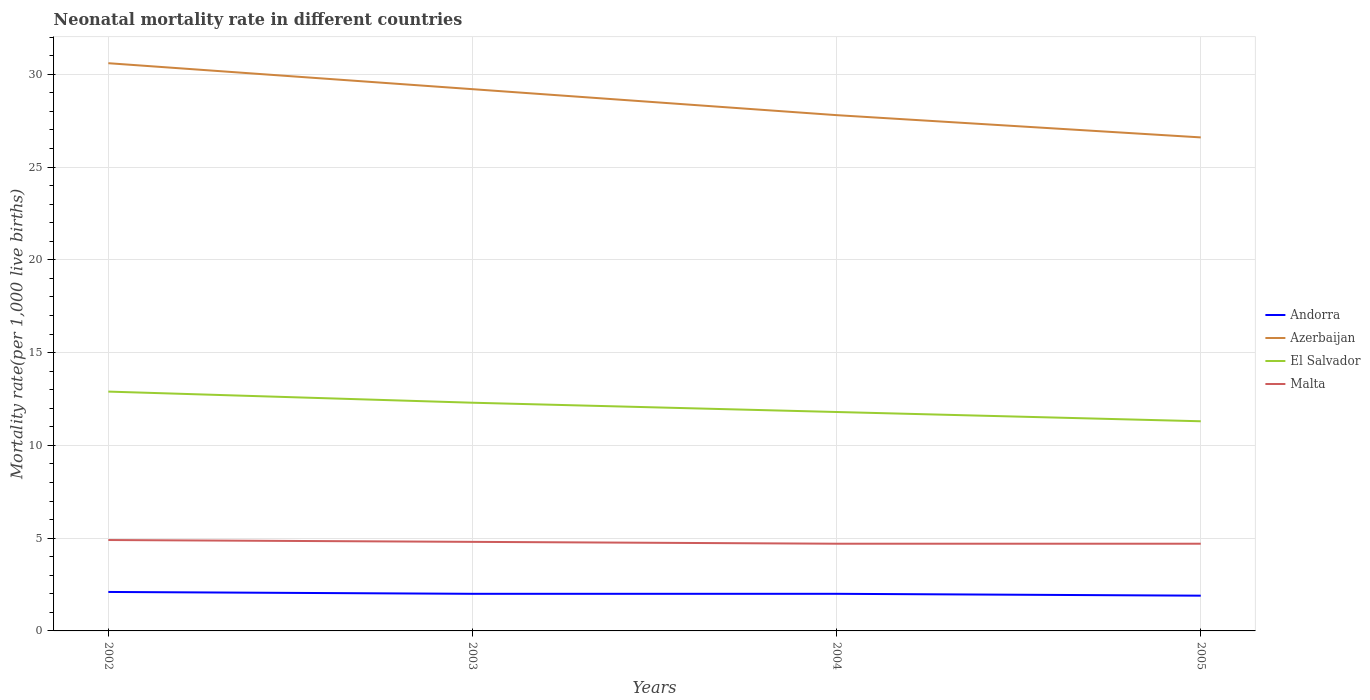What is the total neonatal mortality rate in Malta in the graph?
Provide a short and direct response. 0.2. What is the difference between the highest and the second highest neonatal mortality rate in Azerbaijan?
Provide a short and direct response. 4. Is the neonatal mortality rate in Andorra strictly greater than the neonatal mortality rate in El Salvador over the years?
Offer a terse response. Yes. How many years are there in the graph?
Your answer should be very brief. 4. Are the values on the major ticks of Y-axis written in scientific E-notation?
Your answer should be compact. No. Does the graph contain any zero values?
Provide a short and direct response. No. Does the graph contain grids?
Give a very brief answer. Yes. Where does the legend appear in the graph?
Ensure brevity in your answer.  Center right. How are the legend labels stacked?
Offer a very short reply. Vertical. What is the title of the graph?
Make the answer very short. Neonatal mortality rate in different countries. Does "Moldova" appear as one of the legend labels in the graph?
Keep it short and to the point. No. What is the label or title of the X-axis?
Your response must be concise. Years. What is the label or title of the Y-axis?
Offer a terse response. Mortality rate(per 1,0 live births). What is the Mortality rate(per 1,000 live births) in Azerbaijan in 2002?
Offer a very short reply. 30.6. What is the Mortality rate(per 1,000 live births) in Malta in 2002?
Your response must be concise. 4.9. What is the Mortality rate(per 1,000 live births) in Andorra in 2003?
Offer a terse response. 2. What is the Mortality rate(per 1,000 live births) of Azerbaijan in 2003?
Give a very brief answer. 29.2. What is the Mortality rate(per 1,000 live births) in El Salvador in 2003?
Ensure brevity in your answer.  12.3. What is the Mortality rate(per 1,000 live births) in Malta in 2003?
Your answer should be very brief. 4.8. What is the Mortality rate(per 1,000 live births) in Andorra in 2004?
Ensure brevity in your answer.  2. What is the Mortality rate(per 1,000 live births) in Azerbaijan in 2004?
Your response must be concise. 27.8. What is the Mortality rate(per 1,000 live births) of El Salvador in 2004?
Make the answer very short. 11.8. What is the Mortality rate(per 1,000 live births) in Malta in 2004?
Ensure brevity in your answer.  4.7. What is the Mortality rate(per 1,000 live births) of Andorra in 2005?
Keep it short and to the point. 1.9. What is the Mortality rate(per 1,000 live births) of Azerbaijan in 2005?
Your answer should be very brief. 26.6. What is the Mortality rate(per 1,000 live births) of Malta in 2005?
Your answer should be compact. 4.7. Across all years, what is the maximum Mortality rate(per 1,000 live births) of Azerbaijan?
Give a very brief answer. 30.6. Across all years, what is the maximum Mortality rate(per 1,000 live births) of Malta?
Offer a terse response. 4.9. Across all years, what is the minimum Mortality rate(per 1,000 live births) of Andorra?
Ensure brevity in your answer.  1.9. Across all years, what is the minimum Mortality rate(per 1,000 live births) in Azerbaijan?
Make the answer very short. 26.6. Across all years, what is the minimum Mortality rate(per 1,000 live births) in Malta?
Offer a very short reply. 4.7. What is the total Mortality rate(per 1,000 live births) in Andorra in the graph?
Provide a succinct answer. 8. What is the total Mortality rate(per 1,000 live births) of Azerbaijan in the graph?
Give a very brief answer. 114.2. What is the total Mortality rate(per 1,000 live births) of El Salvador in the graph?
Make the answer very short. 48.3. What is the difference between the Mortality rate(per 1,000 live births) in Andorra in 2002 and that in 2003?
Your answer should be very brief. 0.1. What is the difference between the Mortality rate(per 1,000 live births) of Azerbaijan in 2002 and that in 2003?
Give a very brief answer. 1.4. What is the difference between the Mortality rate(per 1,000 live births) in El Salvador in 2002 and that in 2003?
Offer a terse response. 0.6. What is the difference between the Mortality rate(per 1,000 live births) of Andorra in 2002 and that in 2004?
Make the answer very short. 0.1. What is the difference between the Mortality rate(per 1,000 live births) in Azerbaijan in 2002 and that in 2004?
Provide a short and direct response. 2.8. What is the difference between the Mortality rate(per 1,000 live births) in Malta in 2002 and that in 2004?
Your answer should be very brief. 0.2. What is the difference between the Mortality rate(per 1,000 live births) in El Salvador in 2002 and that in 2005?
Offer a very short reply. 1.6. What is the difference between the Mortality rate(per 1,000 live births) in Andorra in 2003 and that in 2004?
Offer a terse response. 0. What is the difference between the Mortality rate(per 1,000 live births) in Azerbaijan in 2003 and that in 2004?
Provide a succinct answer. 1.4. What is the difference between the Mortality rate(per 1,000 live births) of El Salvador in 2003 and that in 2004?
Provide a succinct answer. 0.5. What is the difference between the Mortality rate(per 1,000 live births) of Malta in 2003 and that in 2004?
Offer a terse response. 0.1. What is the difference between the Mortality rate(per 1,000 live births) of Andorra in 2003 and that in 2005?
Provide a short and direct response. 0.1. What is the difference between the Mortality rate(per 1,000 live births) in El Salvador in 2003 and that in 2005?
Offer a terse response. 1. What is the difference between the Mortality rate(per 1,000 live births) in Malta in 2003 and that in 2005?
Offer a very short reply. 0.1. What is the difference between the Mortality rate(per 1,000 live births) in Malta in 2004 and that in 2005?
Your answer should be compact. 0. What is the difference between the Mortality rate(per 1,000 live births) of Andorra in 2002 and the Mortality rate(per 1,000 live births) of Azerbaijan in 2003?
Offer a very short reply. -27.1. What is the difference between the Mortality rate(per 1,000 live births) in Andorra in 2002 and the Mortality rate(per 1,000 live births) in El Salvador in 2003?
Provide a succinct answer. -10.2. What is the difference between the Mortality rate(per 1,000 live births) in Andorra in 2002 and the Mortality rate(per 1,000 live births) in Malta in 2003?
Ensure brevity in your answer.  -2.7. What is the difference between the Mortality rate(per 1,000 live births) in Azerbaijan in 2002 and the Mortality rate(per 1,000 live births) in Malta in 2003?
Provide a succinct answer. 25.8. What is the difference between the Mortality rate(per 1,000 live births) in El Salvador in 2002 and the Mortality rate(per 1,000 live births) in Malta in 2003?
Give a very brief answer. 8.1. What is the difference between the Mortality rate(per 1,000 live births) of Andorra in 2002 and the Mortality rate(per 1,000 live births) of Azerbaijan in 2004?
Your response must be concise. -25.7. What is the difference between the Mortality rate(per 1,000 live births) in Andorra in 2002 and the Mortality rate(per 1,000 live births) in Malta in 2004?
Keep it short and to the point. -2.6. What is the difference between the Mortality rate(per 1,000 live births) in Azerbaijan in 2002 and the Mortality rate(per 1,000 live births) in El Salvador in 2004?
Your answer should be compact. 18.8. What is the difference between the Mortality rate(per 1,000 live births) in Azerbaijan in 2002 and the Mortality rate(per 1,000 live births) in Malta in 2004?
Your response must be concise. 25.9. What is the difference between the Mortality rate(per 1,000 live births) in Andorra in 2002 and the Mortality rate(per 1,000 live births) in Azerbaijan in 2005?
Ensure brevity in your answer.  -24.5. What is the difference between the Mortality rate(per 1,000 live births) in Andorra in 2002 and the Mortality rate(per 1,000 live births) in El Salvador in 2005?
Offer a very short reply. -9.2. What is the difference between the Mortality rate(per 1,000 live births) of Andorra in 2002 and the Mortality rate(per 1,000 live births) of Malta in 2005?
Keep it short and to the point. -2.6. What is the difference between the Mortality rate(per 1,000 live births) in Azerbaijan in 2002 and the Mortality rate(per 1,000 live births) in El Salvador in 2005?
Keep it short and to the point. 19.3. What is the difference between the Mortality rate(per 1,000 live births) in Azerbaijan in 2002 and the Mortality rate(per 1,000 live births) in Malta in 2005?
Give a very brief answer. 25.9. What is the difference between the Mortality rate(per 1,000 live births) of El Salvador in 2002 and the Mortality rate(per 1,000 live births) of Malta in 2005?
Make the answer very short. 8.2. What is the difference between the Mortality rate(per 1,000 live births) in Andorra in 2003 and the Mortality rate(per 1,000 live births) in Azerbaijan in 2004?
Ensure brevity in your answer.  -25.8. What is the difference between the Mortality rate(per 1,000 live births) of Andorra in 2003 and the Mortality rate(per 1,000 live births) of Malta in 2004?
Ensure brevity in your answer.  -2.7. What is the difference between the Mortality rate(per 1,000 live births) of Azerbaijan in 2003 and the Mortality rate(per 1,000 live births) of El Salvador in 2004?
Keep it short and to the point. 17.4. What is the difference between the Mortality rate(per 1,000 live births) in Andorra in 2003 and the Mortality rate(per 1,000 live births) in Azerbaijan in 2005?
Ensure brevity in your answer.  -24.6. What is the difference between the Mortality rate(per 1,000 live births) of Andorra in 2003 and the Mortality rate(per 1,000 live births) of El Salvador in 2005?
Give a very brief answer. -9.3. What is the difference between the Mortality rate(per 1,000 live births) in Andorra in 2003 and the Mortality rate(per 1,000 live births) in Malta in 2005?
Your answer should be very brief. -2.7. What is the difference between the Mortality rate(per 1,000 live births) in El Salvador in 2003 and the Mortality rate(per 1,000 live births) in Malta in 2005?
Your response must be concise. 7.6. What is the difference between the Mortality rate(per 1,000 live births) of Andorra in 2004 and the Mortality rate(per 1,000 live births) of Azerbaijan in 2005?
Keep it short and to the point. -24.6. What is the difference between the Mortality rate(per 1,000 live births) of Andorra in 2004 and the Mortality rate(per 1,000 live births) of El Salvador in 2005?
Provide a succinct answer. -9.3. What is the difference between the Mortality rate(per 1,000 live births) of Andorra in 2004 and the Mortality rate(per 1,000 live births) of Malta in 2005?
Offer a very short reply. -2.7. What is the difference between the Mortality rate(per 1,000 live births) in Azerbaijan in 2004 and the Mortality rate(per 1,000 live births) in Malta in 2005?
Your answer should be compact. 23.1. What is the average Mortality rate(per 1,000 live births) in Azerbaijan per year?
Offer a very short reply. 28.55. What is the average Mortality rate(per 1,000 live births) in El Salvador per year?
Your answer should be compact. 12.07. What is the average Mortality rate(per 1,000 live births) of Malta per year?
Your response must be concise. 4.78. In the year 2002, what is the difference between the Mortality rate(per 1,000 live births) in Andorra and Mortality rate(per 1,000 live births) in Azerbaijan?
Your response must be concise. -28.5. In the year 2002, what is the difference between the Mortality rate(per 1,000 live births) in Andorra and Mortality rate(per 1,000 live births) in El Salvador?
Provide a succinct answer. -10.8. In the year 2002, what is the difference between the Mortality rate(per 1,000 live births) in Azerbaijan and Mortality rate(per 1,000 live births) in El Salvador?
Offer a terse response. 17.7. In the year 2002, what is the difference between the Mortality rate(per 1,000 live births) of Azerbaijan and Mortality rate(per 1,000 live births) of Malta?
Your answer should be very brief. 25.7. In the year 2003, what is the difference between the Mortality rate(per 1,000 live births) in Andorra and Mortality rate(per 1,000 live births) in Azerbaijan?
Your response must be concise. -27.2. In the year 2003, what is the difference between the Mortality rate(per 1,000 live births) in Andorra and Mortality rate(per 1,000 live births) in El Salvador?
Your answer should be very brief. -10.3. In the year 2003, what is the difference between the Mortality rate(per 1,000 live births) in Andorra and Mortality rate(per 1,000 live births) in Malta?
Give a very brief answer. -2.8. In the year 2003, what is the difference between the Mortality rate(per 1,000 live births) in Azerbaijan and Mortality rate(per 1,000 live births) in Malta?
Offer a very short reply. 24.4. In the year 2004, what is the difference between the Mortality rate(per 1,000 live births) in Andorra and Mortality rate(per 1,000 live births) in Azerbaijan?
Ensure brevity in your answer.  -25.8. In the year 2004, what is the difference between the Mortality rate(per 1,000 live births) in Azerbaijan and Mortality rate(per 1,000 live births) in El Salvador?
Ensure brevity in your answer.  16. In the year 2004, what is the difference between the Mortality rate(per 1,000 live births) in Azerbaijan and Mortality rate(per 1,000 live births) in Malta?
Offer a very short reply. 23.1. In the year 2005, what is the difference between the Mortality rate(per 1,000 live births) of Andorra and Mortality rate(per 1,000 live births) of Azerbaijan?
Offer a terse response. -24.7. In the year 2005, what is the difference between the Mortality rate(per 1,000 live births) of Andorra and Mortality rate(per 1,000 live births) of El Salvador?
Provide a succinct answer. -9.4. In the year 2005, what is the difference between the Mortality rate(per 1,000 live births) in Andorra and Mortality rate(per 1,000 live births) in Malta?
Keep it short and to the point. -2.8. In the year 2005, what is the difference between the Mortality rate(per 1,000 live births) in Azerbaijan and Mortality rate(per 1,000 live births) in El Salvador?
Ensure brevity in your answer.  15.3. In the year 2005, what is the difference between the Mortality rate(per 1,000 live births) of Azerbaijan and Mortality rate(per 1,000 live births) of Malta?
Your answer should be compact. 21.9. In the year 2005, what is the difference between the Mortality rate(per 1,000 live births) of El Salvador and Mortality rate(per 1,000 live births) of Malta?
Provide a short and direct response. 6.6. What is the ratio of the Mortality rate(per 1,000 live births) of Azerbaijan in 2002 to that in 2003?
Give a very brief answer. 1.05. What is the ratio of the Mortality rate(per 1,000 live births) of El Salvador in 2002 to that in 2003?
Make the answer very short. 1.05. What is the ratio of the Mortality rate(per 1,000 live births) in Malta in 2002 to that in 2003?
Give a very brief answer. 1.02. What is the ratio of the Mortality rate(per 1,000 live births) of Andorra in 2002 to that in 2004?
Offer a terse response. 1.05. What is the ratio of the Mortality rate(per 1,000 live births) in Azerbaijan in 2002 to that in 2004?
Offer a terse response. 1.1. What is the ratio of the Mortality rate(per 1,000 live births) of El Salvador in 2002 to that in 2004?
Your response must be concise. 1.09. What is the ratio of the Mortality rate(per 1,000 live births) of Malta in 2002 to that in 2004?
Provide a succinct answer. 1.04. What is the ratio of the Mortality rate(per 1,000 live births) of Andorra in 2002 to that in 2005?
Offer a very short reply. 1.11. What is the ratio of the Mortality rate(per 1,000 live births) of Azerbaijan in 2002 to that in 2005?
Your response must be concise. 1.15. What is the ratio of the Mortality rate(per 1,000 live births) of El Salvador in 2002 to that in 2005?
Your response must be concise. 1.14. What is the ratio of the Mortality rate(per 1,000 live births) of Malta in 2002 to that in 2005?
Give a very brief answer. 1.04. What is the ratio of the Mortality rate(per 1,000 live births) in Azerbaijan in 2003 to that in 2004?
Give a very brief answer. 1.05. What is the ratio of the Mortality rate(per 1,000 live births) in El Salvador in 2003 to that in 2004?
Your response must be concise. 1.04. What is the ratio of the Mortality rate(per 1,000 live births) in Malta in 2003 to that in 2004?
Make the answer very short. 1.02. What is the ratio of the Mortality rate(per 1,000 live births) of Andorra in 2003 to that in 2005?
Your answer should be compact. 1.05. What is the ratio of the Mortality rate(per 1,000 live births) in Azerbaijan in 2003 to that in 2005?
Give a very brief answer. 1.1. What is the ratio of the Mortality rate(per 1,000 live births) of El Salvador in 2003 to that in 2005?
Provide a succinct answer. 1.09. What is the ratio of the Mortality rate(per 1,000 live births) of Malta in 2003 to that in 2005?
Your answer should be compact. 1.02. What is the ratio of the Mortality rate(per 1,000 live births) in Andorra in 2004 to that in 2005?
Ensure brevity in your answer.  1.05. What is the ratio of the Mortality rate(per 1,000 live births) of Azerbaijan in 2004 to that in 2005?
Ensure brevity in your answer.  1.05. What is the ratio of the Mortality rate(per 1,000 live births) of El Salvador in 2004 to that in 2005?
Make the answer very short. 1.04. What is the ratio of the Mortality rate(per 1,000 live births) of Malta in 2004 to that in 2005?
Keep it short and to the point. 1. What is the difference between the highest and the second highest Mortality rate(per 1,000 live births) of Andorra?
Offer a very short reply. 0.1. What is the difference between the highest and the lowest Mortality rate(per 1,000 live births) of Andorra?
Offer a terse response. 0.2. What is the difference between the highest and the lowest Mortality rate(per 1,000 live births) of Malta?
Offer a terse response. 0.2. 